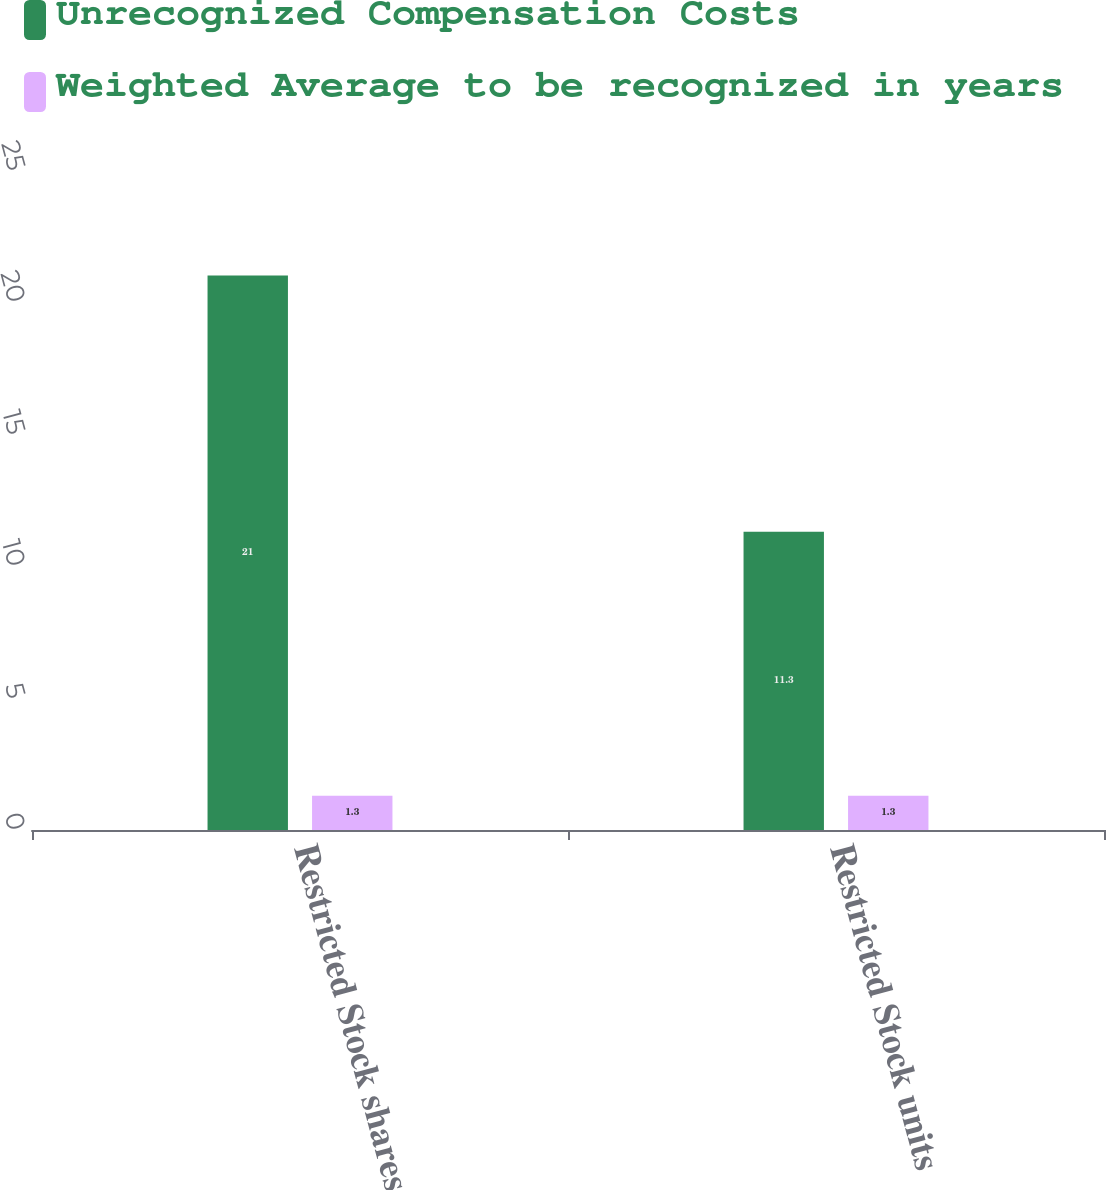Convert chart to OTSL. <chart><loc_0><loc_0><loc_500><loc_500><stacked_bar_chart><ecel><fcel>Restricted Stock shares<fcel>Restricted Stock units<nl><fcel>Unrecognized Compensation Costs<fcel>21<fcel>11.3<nl><fcel>Weighted Average to be recognized in years<fcel>1.3<fcel>1.3<nl></chart> 